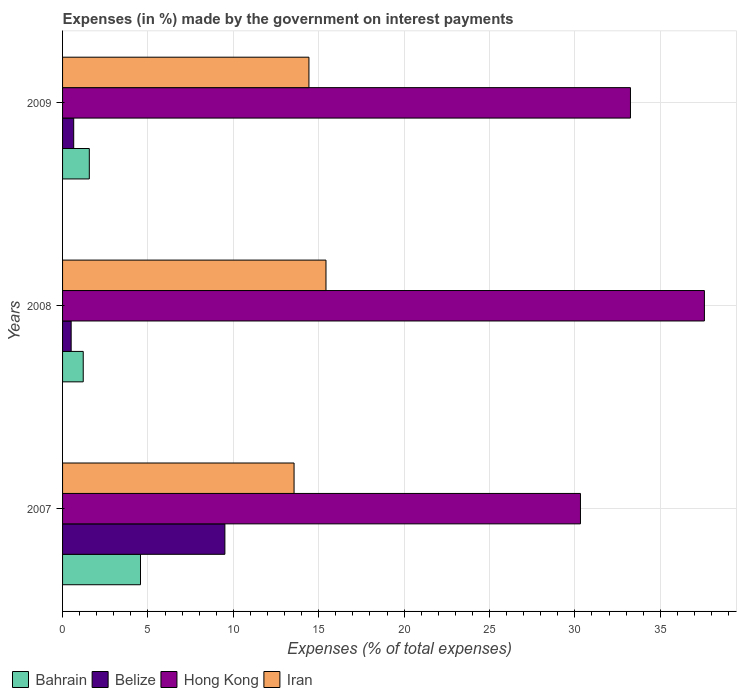How many groups of bars are there?
Make the answer very short. 3. Are the number of bars per tick equal to the number of legend labels?
Keep it short and to the point. Yes. How many bars are there on the 2nd tick from the top?
Your answer should be very brief. 4. How many bars are there on the 2nd tick from the bottom?
Your answer should be very brief. 4. What is the label of the 2nd group of bars from the top?
Offer a terse response. 2008. What is the percentage of expenses made by the government on interest payments in Hong Kong in 2007?
Provide a short and direct response. 30.33. Across all years, what is the maximum percentage of expenses made by the government on interest payments in Iran?
Your answer should be very brief. 15.43. Across all years, what is the minimum percentage of expenses made by the government on interest payments in Iran?
Ensure brevity in your answer.  13.56. In which year was the percentage of expenses made by the government on interest payments in Belize maximum?
Provide a succinct answer. 2007. In which year was the percentage of expenses made by the government on interest payments in Hong Kong minimum?
Offer a very short reply. 2007. What is the total percentage of expenses made by the government on interest payments in Belize in the graph?
Offer a terse response. 10.66. What is the difference between the percentage of expenses made by the government on interest payments in Bahrain in 2007 and that in 2009?
Keep it short and to the point. 3. What is the difference between the percentage of expenses made by the government on interest payments in Hong Kong in 2009 and the percentage of expenses made by the government on interest payments in Iran in 2007?
Provide a succinct answer. 19.7. What is the average percentage of expenses made by the government on interest payments in Belize per year?
Your answer should be compact. 3.55. In the year 2009, what is the difference between the percentage of expenses made by the government on interest payments in Iran and percentage of expenses made by the government on interest payments in Belize?
Give a very brief answer. 13.77. What is the ratio of the percentage of expenses made by the government on interest payments in Belize in 2007 to that in 2008?
Provide a succinct answer. 18.88. Is the difference between the percentage of expenses made by the government on interest payments in Iran in 2007 and 2009 greater than the difference between the percentage of expenses made by the government on interest payments in Belize in 2007 and 2009?
Give a very brief answer. No. What is the difference between the highest and the second highest percentage of expenses made by the government on interest payments in Iran?
Ensure brevity in your answer.  1. What is the difference between the highest and the lowest percentage of expenses made by the government on interest payments in Hong Kong?
Your answer should be very brief. 7.26. Is it the case that in every year, the sum of the percentage of expenses made by the government on interest payments in Iran and percentage of expenses made by the government on interest payments in Belize is greater than the sum of percentage of expenses made by the government on interest payments in Bahrain and percentage of expenses made by the government on interest payments in Hong Kong?
Give a very brief answer. Yes. What does the 4th bar from the top in 2007 represents?
Provide a short and direct response. Bahrain. What does the 1st bar from the bottom in 2008 represents?
Offer a terse response. Bahrain. How many years are there in the graph?
Provide a short and direct response. 3. What is the difference between two consecutive major ticks on the X-axis?
Your answer should be compact. 5. Does the graph contain any zero values?
Provide a succinct answer. No. Does the graph contain grids?
Offer a terse response. Yes. How many legend labels are there?
Make the answer very short. 4. How are the legend labels stacked?
Keep it short and to the point. Horizontal. What is the title of the graph?
Ensure brevity in your answer.  Expenses (in %) made by the government on interest payments. Does "Guam" appear as one of the legend labels in the graph?
Give a very brief answer. No. What is the label or title of the X-axis?
Keep it short and to the point. Expenses (% of total expenses). What is the Expenses (% of total expenses) in Bahrain in 2007?
Make the answer very short. 4.56. What is the Expenses (% of total expenses) in Belize in 2007?
Offer a terse response. 9.51. What is the Expenses (% of total expenses) of Hong Kong in 2007?
Provide a short and direct response. 30.33. What is the Expenses (% of total expenses) of Iran in 2007?
Provide a succinct answer. 13.56. What is the Expenses (% of total expenses) in Bahrain in 2008?
Your answer should be very brief. 1.21. What is the Expenses (% of total expenses) of Belize in 2008?
Make the answer very short. 0.5. What is the Expenses (% of total expenses) of Hong Kong in 2008?
Give a very brief answer. 37.59. What is the Expenses (% of total expenses) of Iran in 2008?
Provide a short and direct response. 15.43. What is the Expenses (% of total expenses) in Bahrain in 2009?
Provide a short and direct response. 1.57. What is the Expenses (% of total expenses) of Belize in 2009?
Provide a short and direct response. 0.65. What is the Expenses (% of total expenses) in Hong Kong in 2009?
Keep it short and to the point. 33.26. What is the Expenses (% of total expenses) in Iran in 2009?
Give a very brief answer. 14.43. Across all years, what is the maximum Expenses (% of total expenses) of Bahrain?
Your answer should be very brief. 4.56. Across all years, what is the maximum Expenses (% of total expenses) in Belize?
Provide a short and direct response. 9.51. Across all years, what is the maximum Expenses (% of total expenses) in Hong Kong?
Offer a terse response. 37.59. Across all years, what is the maximum Expenses (% of total expenses) of Iran?
Make the answer very short. 15.43. Across all years, what is the minimum Expenses (% of total expenses) in Bahrain?
Your answer should be very brief. 1.21. Across all years, what is the minimum Expenses (% of total expenses) of Belize?
Your answer should be compact. 0.5. Across all years, what is the minimum Expenses (% of total expenses) in Hong Kong?
Provide a short and direct response. 30.33. Across all years, what is the minimum Expenses (% of total expenses) in Iran?
Make the answer very short. 13.56. What is the total Expenses (% of total expenses) of Bahrain in the graph?
Ensure brevity in your answer.  7.34. What is the total Expenses (% of total expenses) of Belize in the graph?
Give a very brief answer. 10.66. What is the total Expenses (% of total expenses) of Hong Kong in the graph?
Give a very brief answer. 101.17. What is the total Expenses (% of total expenses) of Iran in the graph?
Offer a terse response. 43.41. What is the difference between the Expenses (% of total expenses) of Bahrain in 2007 and that in 2008?
Offer a very short reply. 3.35. What is the difference between the Expenses (% of total expenses) of Belize in 2007 and that in 2008?
Provide a succinct answer. 9. What is the difference between the Expenses (% of total expenses) of Hong Kong in 2007 and that in 2008?
Keep it short and to the point. -7.26. What is the difference between the Expenses (% of total expenses) of Iran in 2007 and that in 2008?
Ensure brevity in your answer.  -1.87. What is the difference between the Expenses (% of total expenses) in Bahrain in 2007 and that in 2009?
Give a very brief answer. 3. What is the difference between the Expenses (% of total expenses) in Belize in 2007 and that in 2009?
Your answer should be compact. 8.85. What is the difference between the Expenses (% of total expenses) in Hong Kong in 2007 and that in 2009?
Keep it short and to the point. -2.93. What is the difference between the Expenses (% of total expenses) of Iran in 2007 and that in 2009?
Ensure brevity in your answer.  -0.87. What is the difference between the Expenses (% of total expenses) of Bahrain in 2008 and that in 2009?
Your answer should be very brief. -0.36. What is the difference between the Expenses (% of total expenses) in Belize in 2008 and that in 2009?
Provide a short and direct response. -0.15. What is the difference between the Expenses (% of total expenses) in Hong Kong in 2008 and that in 2009?
Give a very brief answer. 4.33. What is the difference between the Expenses (% of total expenses) in Bahrain in 2007 and the Expenses (% of total expenses) in Belize in 2008?
Keep it short and to the point. 4.06. What is the difference between the Expenses (% of total expenses) in Bahrain in 2007 and the Expenses (% of total expenses) in Hong Kong in 2008?
Make the answer very short. -33.02. What is the difference between the Expenses (% of total expenses) in Bahrain in 2007 and the Expenses (% of total expenses) in Iran in 2008?
Make the answer very short. -10.86. What is the difference between the Expenses (% of total expenses) in Belize in 2007 and the Expenses (% of total expenses) in Hong Kong in 2008?
Ensure brevity in your answer.  -28.08. What is the difference between the Expenses (% of total expenses) in Belize in 2007 and the Expenses (% of total expenses) in Iran in 2008?
Offer a very short reply. -5.92. What is the difference between the Expenses (% of total expenses) in Hong Kong in 2007 and the Expenses (% of total expenses) in Iran in 2008?
Ensure brevity in your answer.  14.9. What is the difference between the Expenses (% of total expenses) of Bahrain in 2007 and the Expenses (% of total expenses) of Belize in 2009?
Your answer should be very brief. 3.91. What is the difference between the Expenses (% of total expenses) in Bahrain in 2007 and the Expenses (% of total expenses) in Hong Kong in 2009?
Offer a terse response. -28.69. What is the difference between the Expenses (% of total expenses) in Bahrain in 2007 and the Expenses (% of total expenses) in Iran in 2009?
Ensure brevity in your answer.  -9.86. What is the difference between the Expenses (% of total expenses) in Belize in 2007 and the Expenses (% of total expenses) in Hong Kong in 2009?
Your answer should be very brief. -23.75. What is the difference between the Expenses (% of total expenses) of Belize in 2007 and the Expenses (% of total expenses) of Iran in 2009?
Make the answer very short. -4.92. What is the difference between the Expenses (% of total expenses) in Bahrain in 2008 and the Expenses (% of total expenses) in Belize in 2009?
Offer a terse response. 0.56. What is the difference between the Expenses (% of total expenses) of Bahrain in 2008 and the Expenses (% of total expenses) of Hong Kong in 2009?
Provide a succinct answer. -32.05. What is the difference between the Expenses (% of total expenses) of Bahrain in 2008 and the Expenses (% of total expenses) of Iran in 2009?
Your answer should be compact. -13.22. What is the difference between the Expenses (% of total expenses) of Belize in 2008 and the Expenses (% of total expenses) of Hong Kong in 2009?
Your answer should be compact. -32.75. What is the difference between the Expenses (% of total expenses) of Belize in 2008 and the Expenses (% of total expenses) of Iran in 2009?
Your answer should be compact. -13.92. What is the difference between the Expenses (% of total expenses) in Hong Kong in 2008 and the Expenses (% of total expenses) in Iran in 2009?
Provide a succinct answer. 23.16. What is the average Expenses (% of total expenses) of Bahrain per year?
Your answer should be very brief. 2.45. What is the average Expenses (% of total expenses) of Belize per year?
Your response must be concise. 3.55. What is the average Expenses (% of total expenses) of Hong Kong per year?
Your response must be concise. 33.72. What is the average Expenses (% of total expenses) of Iran per year?
Ensure brevity in your answer.  14.47. In the year 2007, what is the difference between the Expenses (% of total expenses) of Bahrain and Expenses (% of total expenses) of Belize?
Offer a terse response. -4.94. In the year 2007, what is the difference between the Expenses (% of total expenses) in Bahrain and Expenses (% of total expenses) in Hong Kong?
Give a very brief answer. -25.76. In the year 2007, what is the difference between the Expenses (% of total expenses) of Bahrain and Expenses (% of total expenses) of Iran?
Offer a terse response. -8.99. In the year 2007, what is the difference between the Expenses (% of total expenses) of Belize and Expenses (% of total expenses) of Hong Kong?
Make the answer very short. -20.82. In the year 2007, what is the difference between the Expenses (% of total expenses) of Belize and Expenses (% of total expenses) of Iran?
Ensure brevity in your answer.  -4.05. In the year 2007, what is the difference between the Expenses (% of total expenses) of Hong Kong and Expenses (% of total expenses) of Iran?
Give a very brief answer. 16.77. In the year 2008, what is the difference between the Expenses (% of total expenses) of Bahrain and Expenses (% of total expenses) of Belize?
Your response must be concise. 0.71. In the year 2008, what is the difference between the Expenses (% of total expenses) of Bahrain and Expenses (% of total expenses) of Hong Kong?
Your answer should be very brief. -36.38. In the year 2008, what is the difference between the Expenses (% of total expenses) in Bahrain and Expenses (% of total expenses) in Iran?
Offer a very short reply. -14.22. In the year 2008, what is the difference between the Expenses (% of total expenses) of Belize and Expenses (% of total expenses) of Hong Kong?
Ensure brevity in your answer.  -37.08. In the year 2008, what is the difference between the Expenses (% of total expenses) of Belize and Expenses (% of total expenses) of Iran?
Ensure brevity in your answer.  -14.92. In the year 2008, what is the difference between the Expenses (% of total expenses) of Hong Kong and Expenses (% of total expenses) of Iran?
Your response must be concise. 22.16. In the year 2009, what is the difference between the Expenses (% of total expenses) in Bahrain and Expenses (% of total expenses) in Belize?
Offer a terse response. 0.91. In the year 2009, what is the difference between the Expenses (% of total expenses) in Bahrain and Expenses (% of total expenses) in Hong Kong?
Provide a succinct answer. -31.69. In the year 2009, what is the difference between the Expenses (% of total expenses) in Bahrain and Expenses (% of total expenses) in Iran?
Make the answer very short. -12.86. In the year 2009, what is the difference between the Expenses (% of total expenses) in Belize and Expenses (% of total expenses) in Hong Kong?
Offer a terse response. -32.6. In the year 2009, what is the difference between the Expenses (% of total expenses) of Belize and Expenses (% of total expenses) of Iran?
Ensure brevity in your answer.  -13.77. In the year 2009, what is the difference between the Expenses (% of total expenses) of Hong Kong and Expenses (% of total expenses) of Iran?
Your answer should be very brief. 18.83. What is the ratio of the Expenses (% of total expenses) in Bahrain in 2007 to that in 2008?
Give a very brief answer. 3.77. What is the ratio of the Expenses (% of total expenses) of Belize in 2007 to that in 2008?
Provide a short and direct response. 18.88. What is the ratio of the Expenses (% of total expenses) of Hong Kong in 2007 to that in 2008?
Your response must be concise. 0.81. What is the ratio of the Expenses (% of total expenses) of Iran in 2007 to that in 2008?
Give a very brief answer. 0.88. What is the ratio of the Expenses (% of total expenses) in Bahrain in 2007 to that in 2009?
Keep it short and to the point. 2.91. What is the ratio of the Expenses (% of total expenses) in Belize in 2007 to that in 2009?
Keep it short and to the point. 14.57. What is the ratio of the Expenses (% of total expenses) in Hong Kong in 2007 to that in 2009?
Provide a succinct answer. 0.91. What is the ratio of the Expenses (% of total expenses) of Iran in 2007 to that in 2009?
Your answer should be compact. 0.94. What is the ratio of the Expenses (% of total expenses) in Bahrain in 2008 to that in 2009?
Provide a succinct answer. 0.77. What is the ratio of the Expenses (% of total expenses) of Belize in 2008 to that in 2009?
Provide a short and direct response. 0.77. What is the ratio of the Expenses (% of total expenses) in Hong Kong in 2008 to that in 2009?
Provide a short and direct response. 1.13. What is the ratio of the Expenses (% of total expenses) of Iran in 2008 to that in 2009?
Make the answer very short. 1.07. What is the difference between the highest and the second highest Expenses (% of total expenses) in Bahrain?
Your answer should be compact. 3. What is the difference between the highest and the second highest Expenses (% of total expenses) in Belize?
Provide a short and direct response. 8.85. What is the difference between the highest and the second highest Expenses (% of total expenses) of Hong Kong?
Make the answer very short. 4.33. What is the difference between the highest and the lowest Expenses (% of total expenses) of Bahrain?
Give a very brief answer. 3.35. What is the difference between the highest and the lowest Expenses (% of total expenses) in Belize?
Offer a very short reply. 9. What is the difference between the highest and the lowest Expenses (% of total expenses) of Hong Kong?
Offer a terse response. 7.26. What is the difference between the highest and the lowest Expenses (% of total expenses) in Iran?
Provide a short and direct response. 1.87. 